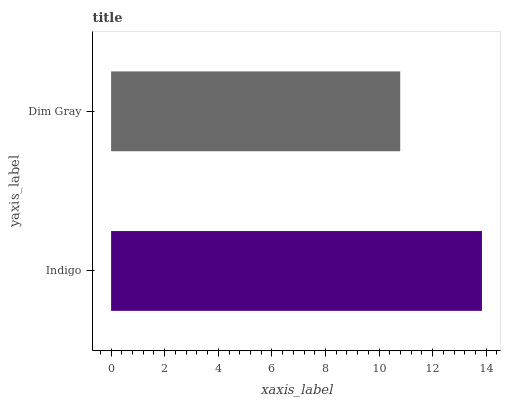Is Dim Gray the minimum?
Answer yes or no. Yes. Is Indigo the maximum?
Answer yes or no. Yes. Is Dim Gray the maximum?
Answer yes or no. No. Is Indigo greater than Dim Gray?
Answer yes or no. Yes. Is Dim Gray less than Indigo?
Answer yes or no. Yes. Is Dim Gray greater than Indigo?
Answer yes or no. No. Is Indigo less than Dim Gray?
Answer yes or no. No. Is Indigo the high median?
Answer yes or no. Yes. Is Dim Gray the low median?
Answer yes or no. Yes. Is Dim Gray the high median?
Answer yes or no. No. Is Indigo the low median?
Answer yes or no. No. 